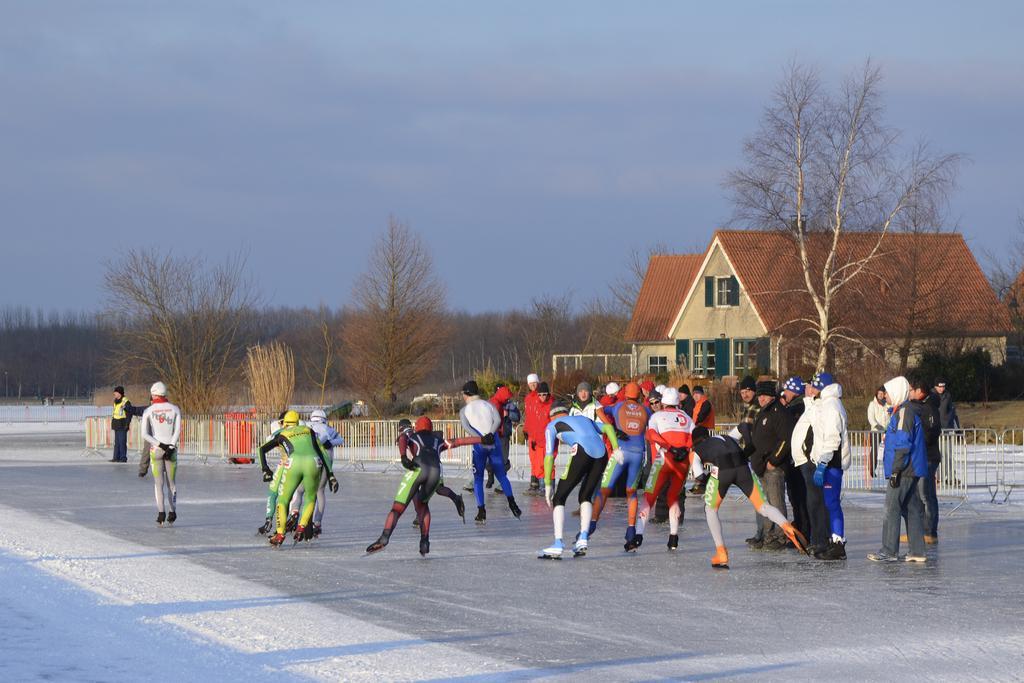Please provide a concise description of this image. In this picture there are people and we can see road, snow, fence, barricades, house, trees and grass. In the background of the image we can see the sky. 